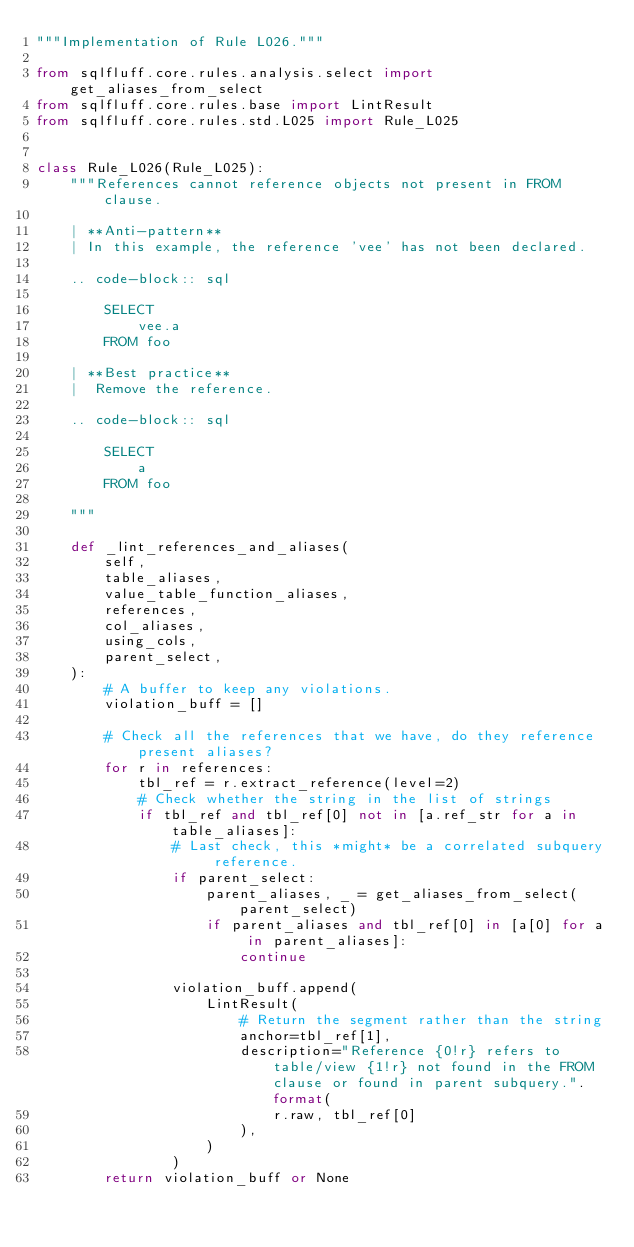<code> <loc_0><loc_0><loc_500><loc_500><_Python_>"""Implementation of Rule L026."""

from sqlfluff.core.rules.analysis.select import get_aliases_from_select
from sqlfluff.core.rules.base import LintResult
from sqlfluff.core.rules.std.L025 import Rule_L025


class Rule_L026(Rule_L025):
    """References cannot reference objects not present in FROM clause.

    | **Anti-pattern**
    | In this example, the reference 'vee' has not been declared.

    .. code-block:: sql

        SELECT
            vee.a
        FROM foo

    | **Best practice**
    |  Remove the reference.

    .. code-block:: sql

        SELECT
            a
        FROM foo

    """

    def _lint_references_and_aliases(
        self,
        table_aliases,
        value_table_function_aliases,
        references,
        col_aliases,
        using_cols,
        parent_select,
    ):
        # A buffer to keep any violations.
        violation_buff = []

        # Check all the references that we have, do they reference present aliases?
        for r in references:
            tbl_ref = r.extract_reference(level=2)
            # Check whether the string in the list of strings
            if tbl_ref and tbl_ref[0] not in [a.ref_str for a in table_aliases]:
                # Last check, this *might* be a correlated subquery reference.
                if parent_select:
                    parent_aliases, _ = get_aliases_from_select(parent_select)
                    if parent_aliases and tbl_ref[0] in [a[0] for a in parent_aliases]:
                        continue

                violation_buff.append(
                    LintResult(
                        # Return the segment rather than the string
                        anchor=tbl_ref[1],
                        description="Reference {0!r} refers to table/view {1!r} not found in the FROM clause or found in parent subquery.".format(
                            r.raw, tbl_ref[0]
                        ),
                    )
                )
        return violation_buff or None
</code> 